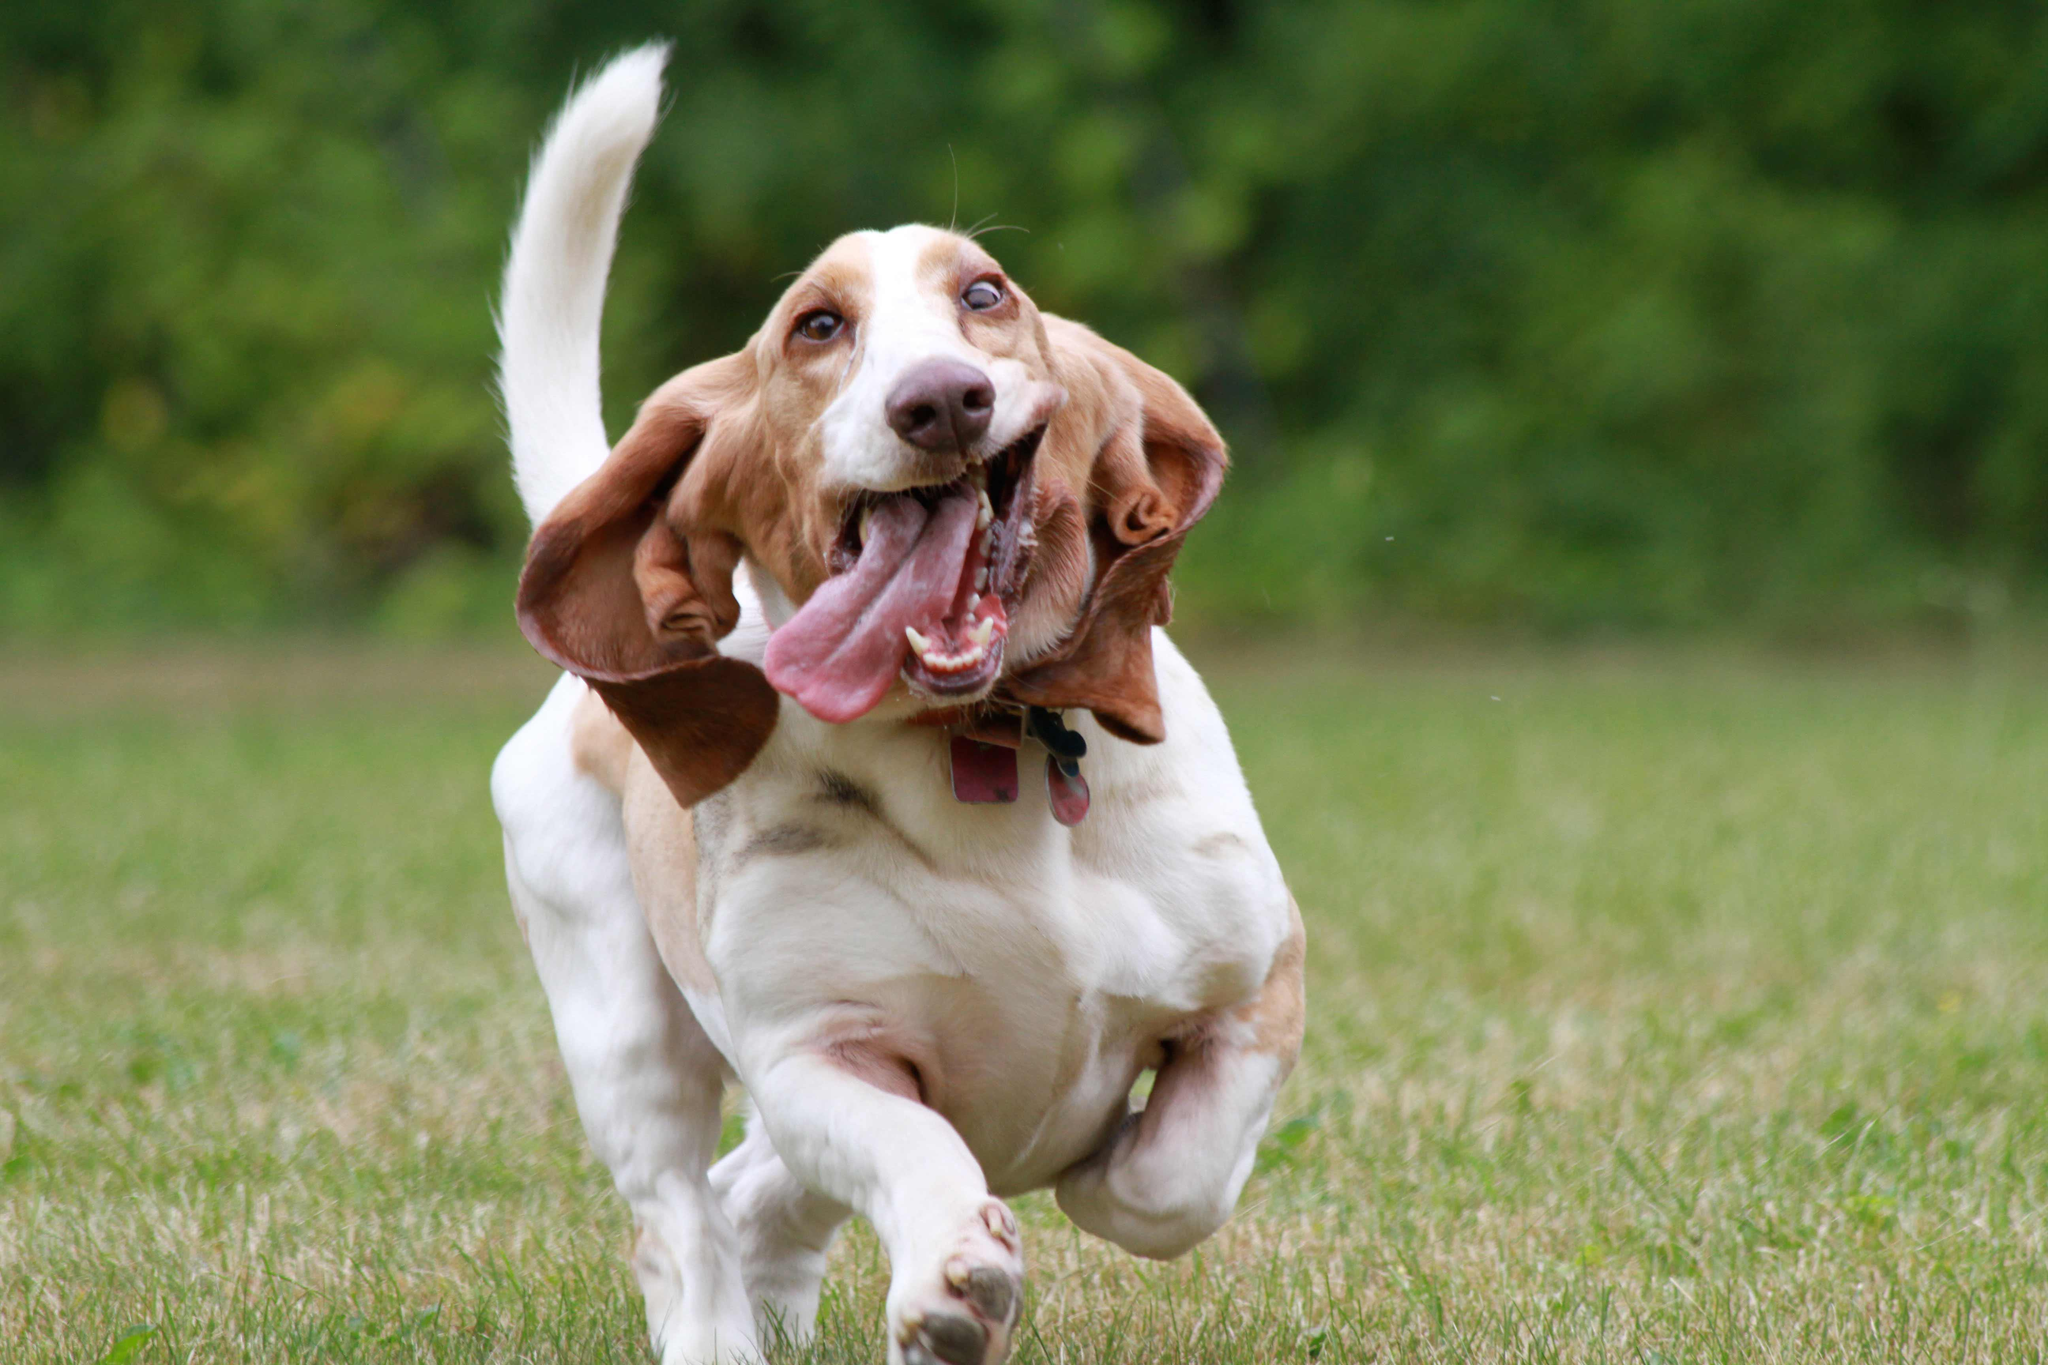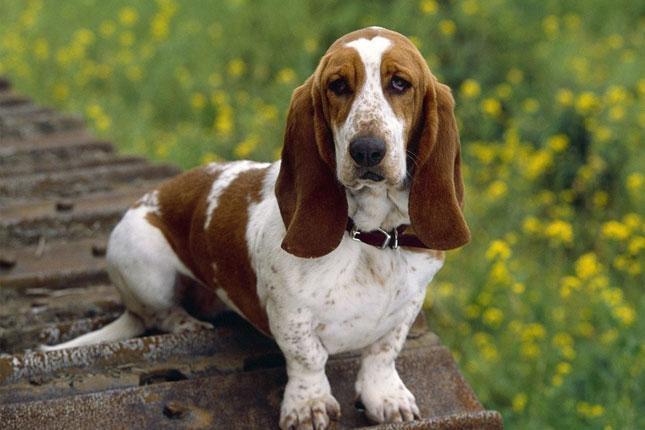The first image is the image on the left, the second image is the image on the right. Evaluate the accuracy of this statement regarding the images: "One of the dogs is sitting on a wooden surface.". Is it true? Answer yes or no. Yes. The first image is the image on the left, the second image is the image on the right. Considering the images on both sides, is "Both dogs are sitting." valid? Answer yes or no. No. 